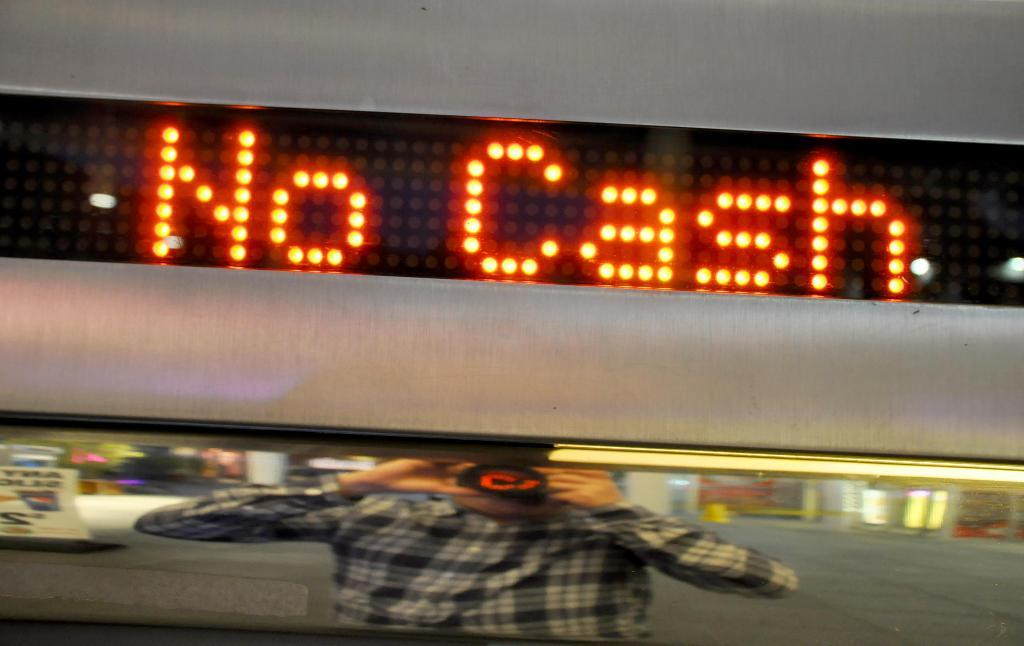Provide a one-sentence caption for the provided image. A person is reflected in a mirror as they take a picture with a sign showing No Cash above it. 